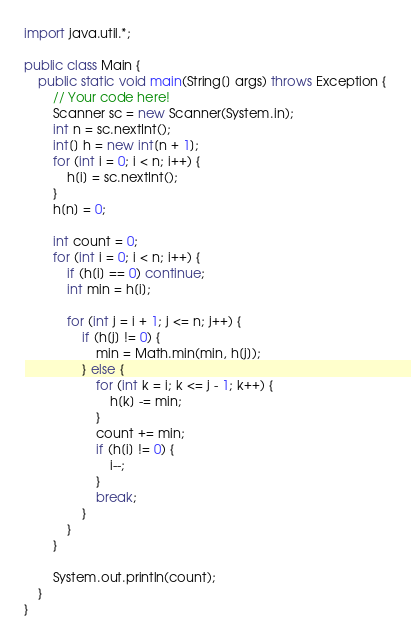Convert code to text. <code><loc_0><loc_0><loc_500><loc_500><_Java_>import java.util.*;

public class Main {
    public static void main(String[] args) throws Exception {
        // Your code here!
        Scanner sc = new Scanner(System.in);
        int n = sc.nextInt();
        int[] h = new int[n + 1];
        for (int i = 0; i < n; i++) {
            h[i] = sc.nextInt();
        }
        h[n] = 0;
        
        int count = 0;
        for (int i = 0; i < n; i++) {
            if (h[i] == 0) continue;
            int min = h[i];
            
            for (int j = i + 1; j <= n; j++) {
                if (h[j] != 0) {
                    min = Math.min(min, h[j]);
                } else {
                    for (int k = i; k <= j - 1; k++) {
                        h[k] -= min;
                    }
                    count += min;
                    if (h[i] != 0) {
                        i--;
                    }
                    break;
                }
            }
        }
        
        System.out.println(count);
    }
}
</code> 